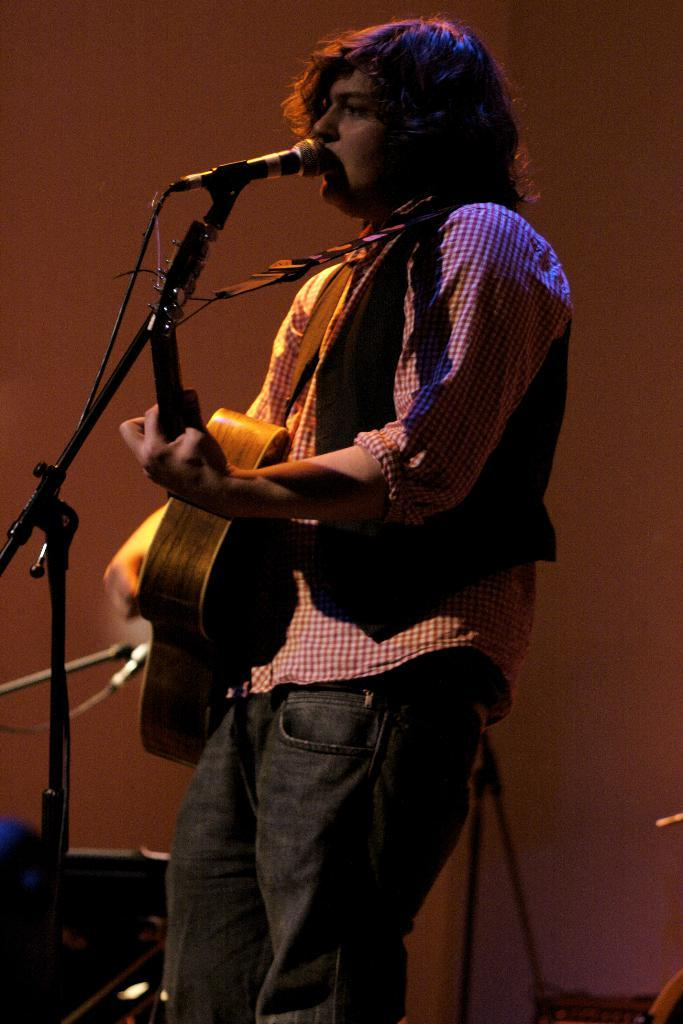What is the main subject of the image? The main subject of the image is a man. What is the man doing in the image? The man is standing, singing, and holding a guitar. What is the man using to amplify his voice in the image? The man is using a microphone. How much salt is present in the image? There is no salt present in the image. What type of town is visible in the background of the image? There is no town visible in the image. What mathematical operation is being performed by the man in the image? The man is not performing any mathematical operation in the image; he is singing while holding a guitar and using a microphone. 